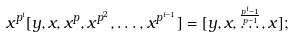Convert formula to latex. <formula><loc_0><loc_0><loc_500><loc_500>x ^ { p ^ { i } } [ y , x , x ^ { p } , x ^ { p ^ { 2 } } , \dots , x ^ { p ^ { i - 1 } } ] = [ y , x , \overset { \frac { p ^ { i } - 1 } { p - 1 } } { \dots } , x ] ;</formula> 